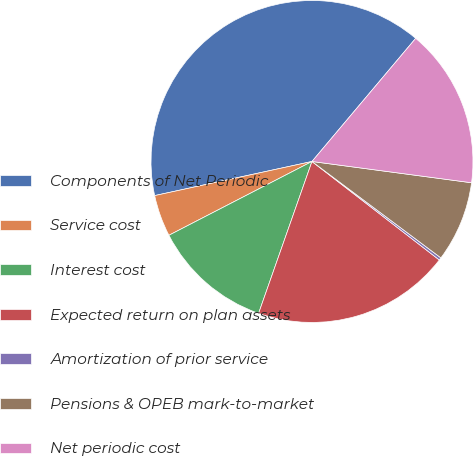<chart> <loc_0><loc_0><loc_500><loc_500><pie_chart><fcel>Components of Net Periodic<fcel>Service cost<fcel>Interest cost<fcel>Expected return on plan assets<fcel>Amortization of prior service<fcel>Pensions & OPEB mark-to-market<fcel>Net periodic cost<nl><fcel>39.54%<fcel>4.18%<fcel>12.04%<fcel>19.9%<fcel>0.26%<fcel>8.11%<fcel>15.97%<nl></chart> 